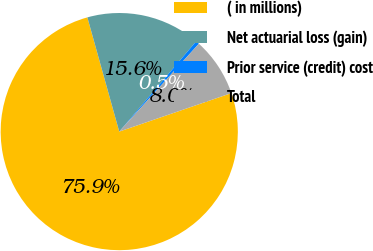Convert chart to OTSL. <chart><loc_0><loc_0><loc_500><loc_500><pie_chart><fcel>( in millions)<fcel>Net actuarial loss (gain)<fcel>Prior service (credit) cost<fcel>Total<nl><fcel>75.93%<fcel>15.57%<fcel>0.48%<fcel>8.02%<nl></chart> 